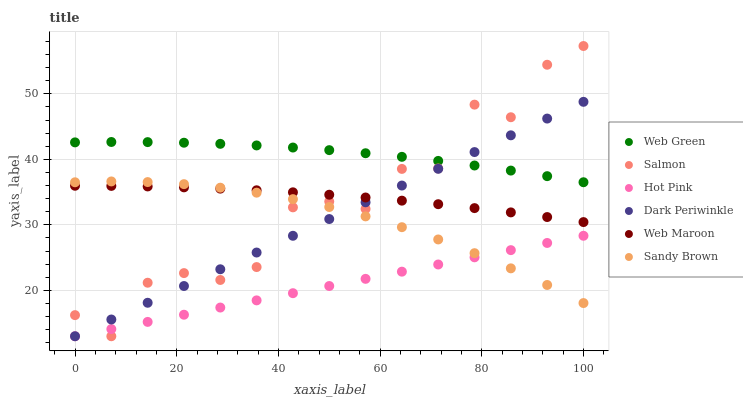Does Hot Pink have the minimum area under the curve?
Answer yes or no. Yes. Does Web Green have the maximum area under the curve?
Answer yes or no. Yes. Does Web Maroon have the minimum area under the curve?
Answer yes or no. No. Does Web Maroon have the maximum area under the curve?
Answer yes or no. No. Is Hot Pink the smoothest?
Answer yes or no. Yes. Is Salmon the roughest?
Answer yes or no. Yes. Is Web Maroon the smoothest?
Answer yes or no. No. Is Web Maroon the roughest?
Answer yes or no. No. Does Salmon have the lowest value?
Answer yes or no. Yes. Does Web Maroon have the lowest value?
Answer yes or no. No. Does Salmon have the highest value?
Answer yes or no. Yes. Does Web Maroon have the highest value?
Answer yes or no. No. Is Sandy Brown less than Web Green?
Answer yes or no. Yes. Is Web Green greater than Sandy Brown?
Answer yes or no. Yes. Does Web Green intersect Salmon?
Answer yes or no. Yes. Is Web Green less than Salmon?
Answer yes or no. No. Is Web Green greater than Salmon?
Answer yes or no. No. Does Sandy Brown intersect Web Green?
Answer yes or no. No. 